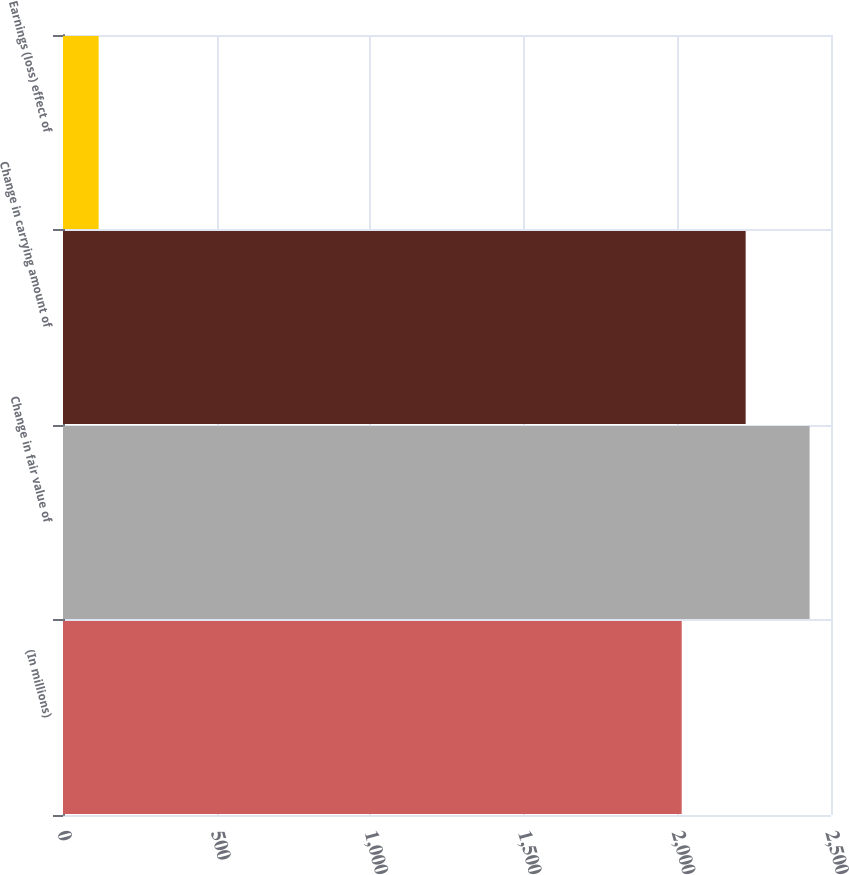Convert chart. <chart><loc_0><loc_0><loc_500><loc_500><bar_chart><fcel>(In millions)<fcel>Change in fair value of<fcel>Change in carrying amount of<fcel>Earnings (loss) effect of<nl><fcel>2014<fcel>2430.4<fcel>2222.2<fcel>116<nl></chart> 